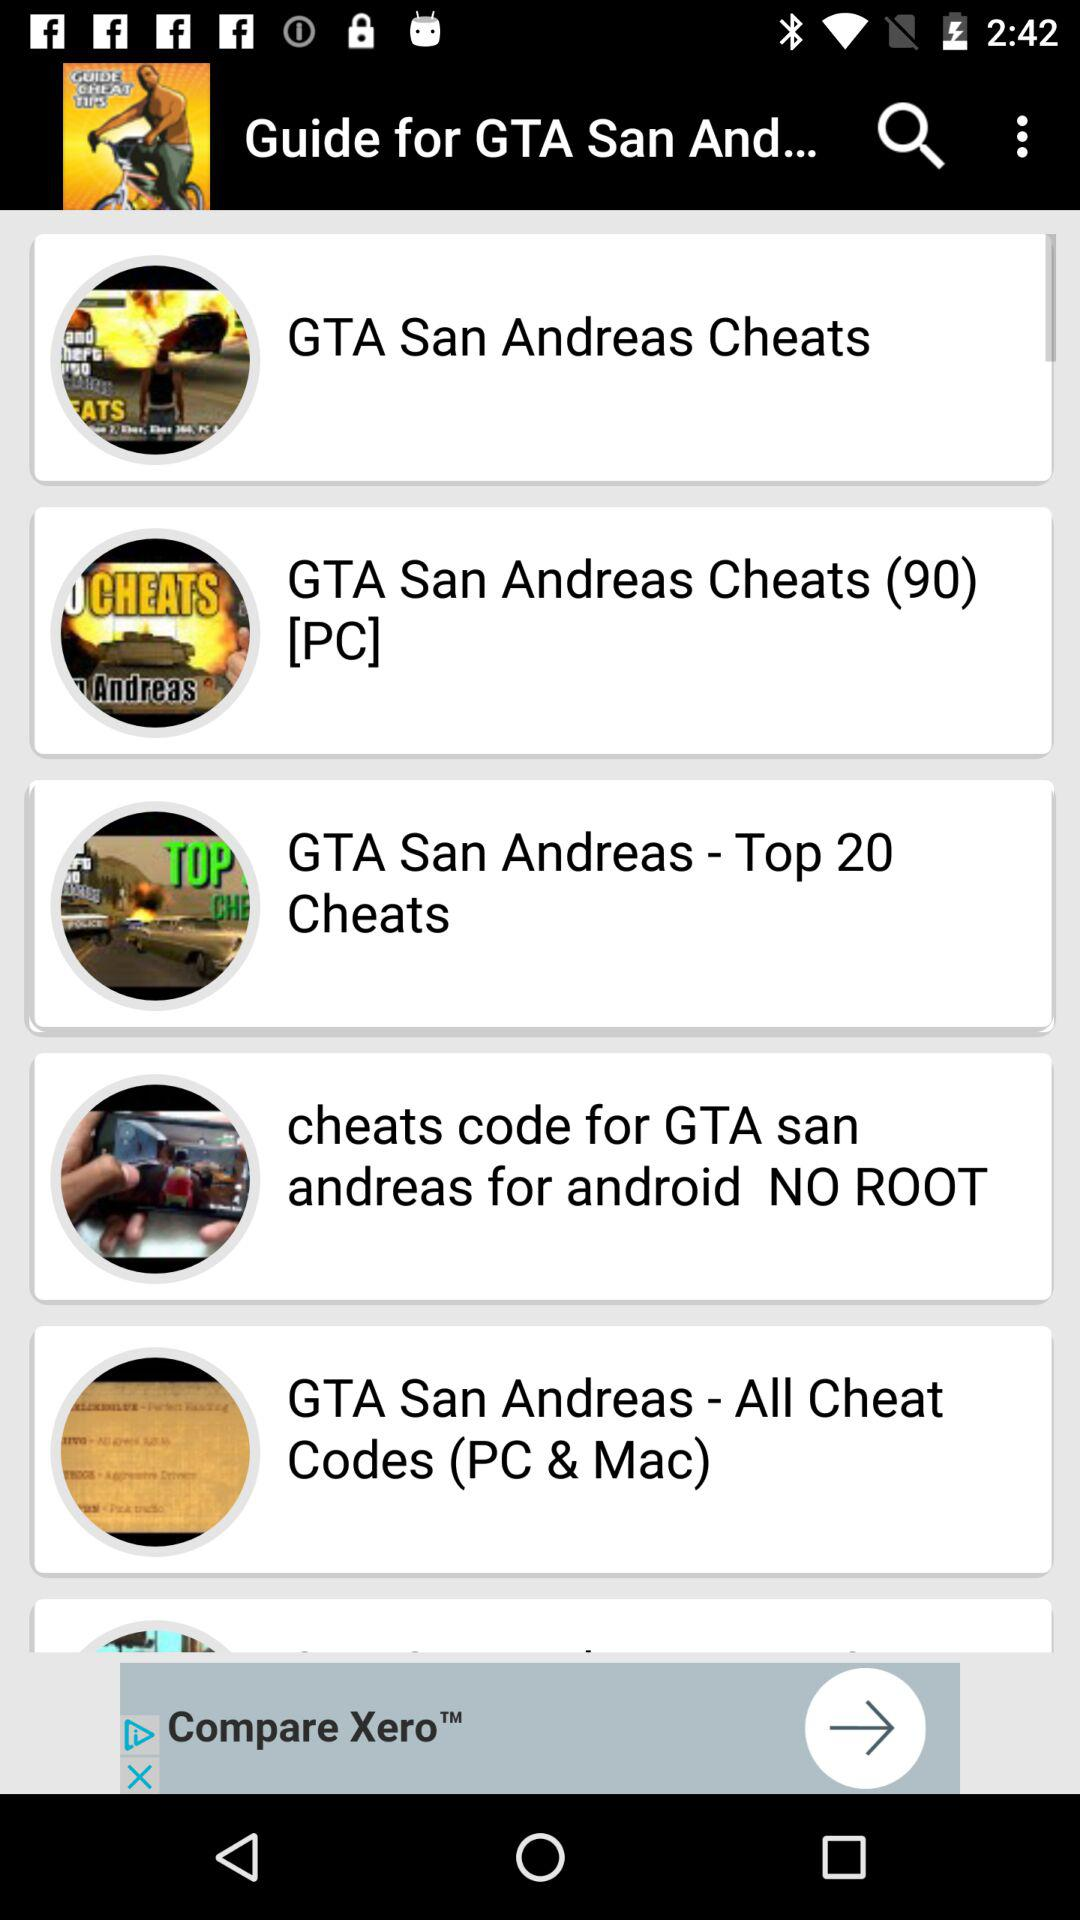What is the application name? The application name is "Guide for GTA San And...". 